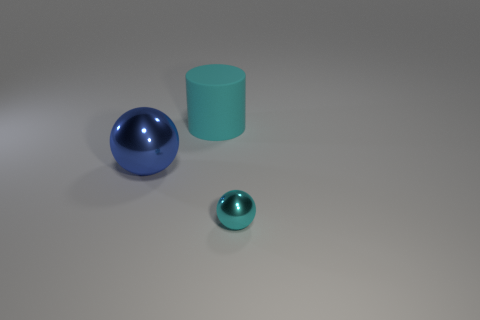Add 3 big cyan objects. How many objects exist? 6 Subtract all spheres. How many objects are left? 1 Subtract 0 cyan blocks. How many objects are left? 3 Subtract all cyan metallic blocks. Subtract all big cyan matte objects. How many objects are left? 2 Add 3 small spheres. How many small spheres are left? 4 Add 3 big cyan rubber cylinders. How many big cyan rubber cylinders exist? 4 